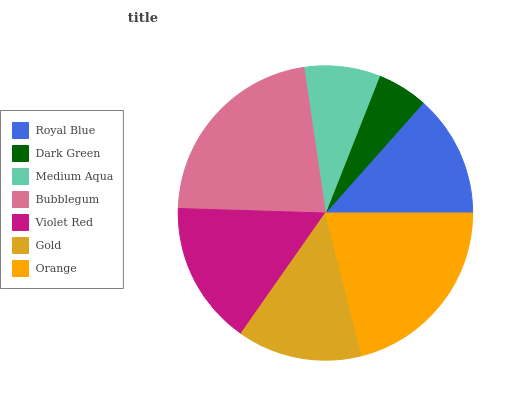Is Dark Green the minimum?
Answer yes or no. Yes. Is Bubblegum the maximum?
Answer yes or no. Yes. Is Medium Aqua the minimum?
Answer yes or no. No. Is Medium Aqua the maximum?
Answer yes or no. No. Is Medium Aqua greater than Dark Green?
Answer yes or no. Yes. Is Dark Green less than Medium Aqua?
Answer yes or no. Yes. Is Dark Green greater than Medium Aqua?
Answer yes or no. No. Is Medium Aqua less than Dark Green?
Answer yes or no. No. Is Gold the high median?
Answer yes or no. Yes. Is Gold the low median?
Answer yes or no. Yes. Is Violet Red the high median?
Answer yes or no. No. Is Medium Aqua the low median?
Answer yes or no. No. 